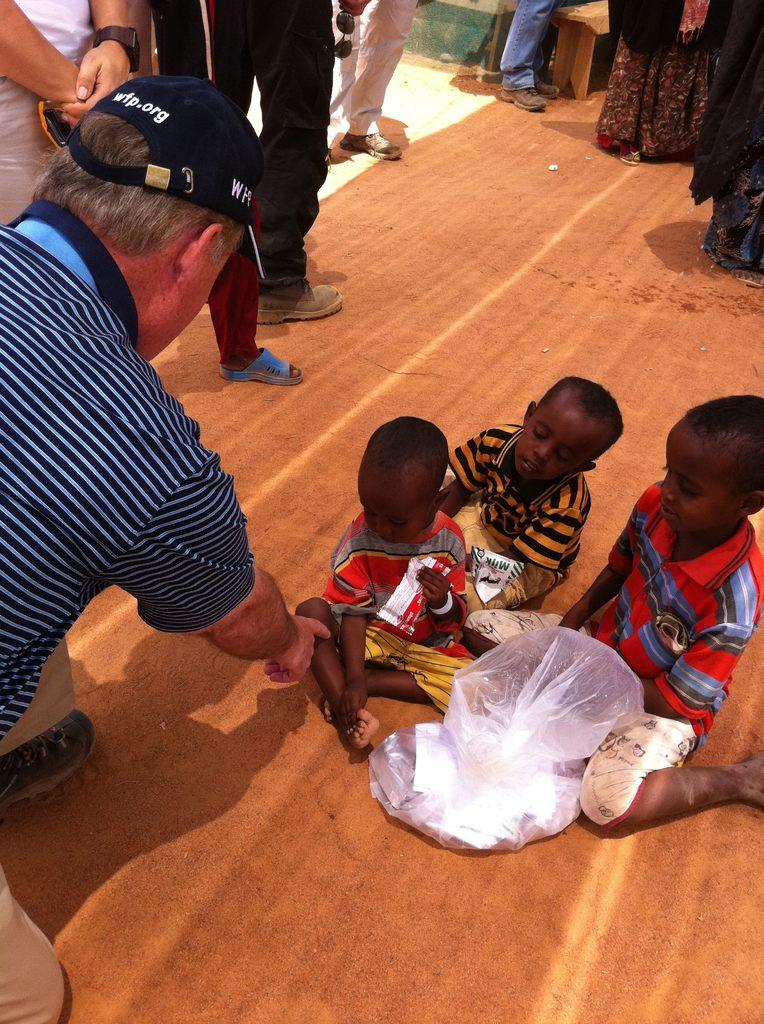Who is present in the image? There are people in the image. Can you describe the position of the kids in the image? There are kids sitting at the bottom of the image. What is placed on the floor in the image? There is a cover placed on the floor. What type of honey is being used to pitch the tent in the image? There is no tent or honey present in the image. What sound can be heard during the thunderstorm in the image? There is no thunderstorm present in the image. 